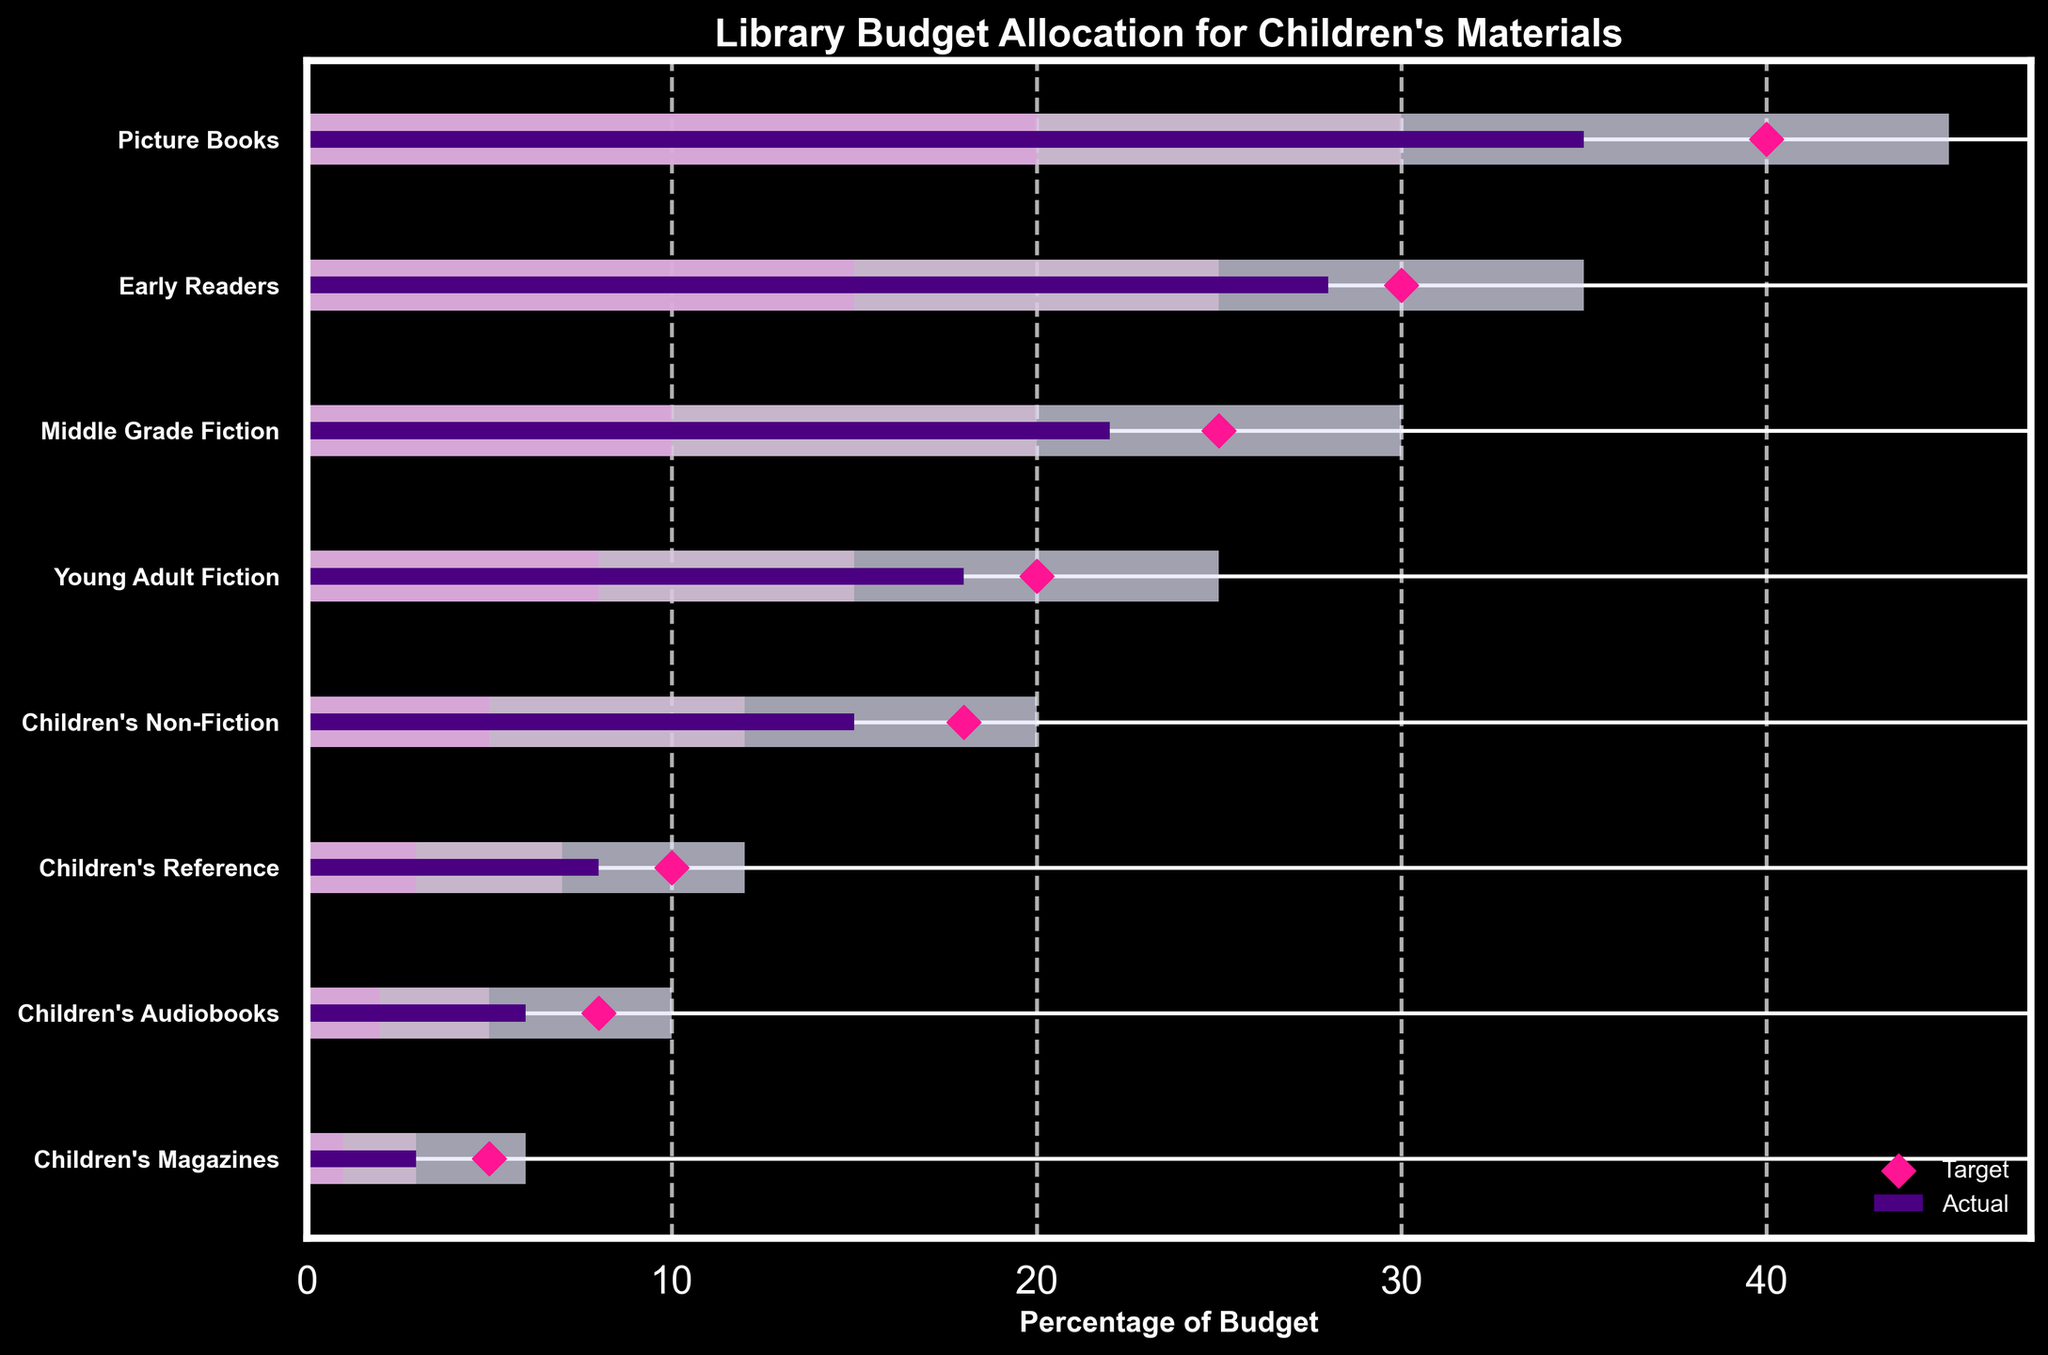What's the title of the chart? The chart's title is displayed at the top of the visual.
Answer: Library Budget Allocation for Children's Materials Which category has the highest actual budget allocation? By observing the length of the bars representing actual values, we see that 'Picture Books' has the longest bar.
Answer: Picture Books What colors are used to represent the ranges in the chart? The chart uses light shades of purple and lavender for the ranges.
Answer: Light purple and lavender shades How many categories are displayed in the chart? Count the number of horizontal bars representing each category.
Answer: 8 Is the actual budget allocation for 'Children's Audiobooks' above or below the target? The actual value bar is shorter than the scatter point (target) for 'Children's Audiobooks'.
Answer: Below Which categories have actual budget allocations that meet or exceed their targets? Compare the length of the actual value bars to their corresponding target scatter points.
Answer: Early Readers What is the difference between the actual and target budget for 'Middle Grade Fiction'? Subtract the actual value from the target value for 'Middle Grade Fiction': 25 - 22 = 3.
Answer: 3 How does the actual budget allocation for 'Young Adult Fiction' compare with that for 'Children's Non-Fiction'? Compare the lengths of the actual value bars for 'Young Adult Fiction' and 'Children's Non-Fiction'.
Answer: Higher What is the combined range for 'Early Readers'? Add the values of Range1, Range2, and Range3 for 'Early Readers': 15 + 10 + 10 = 35.
Answer: 35 